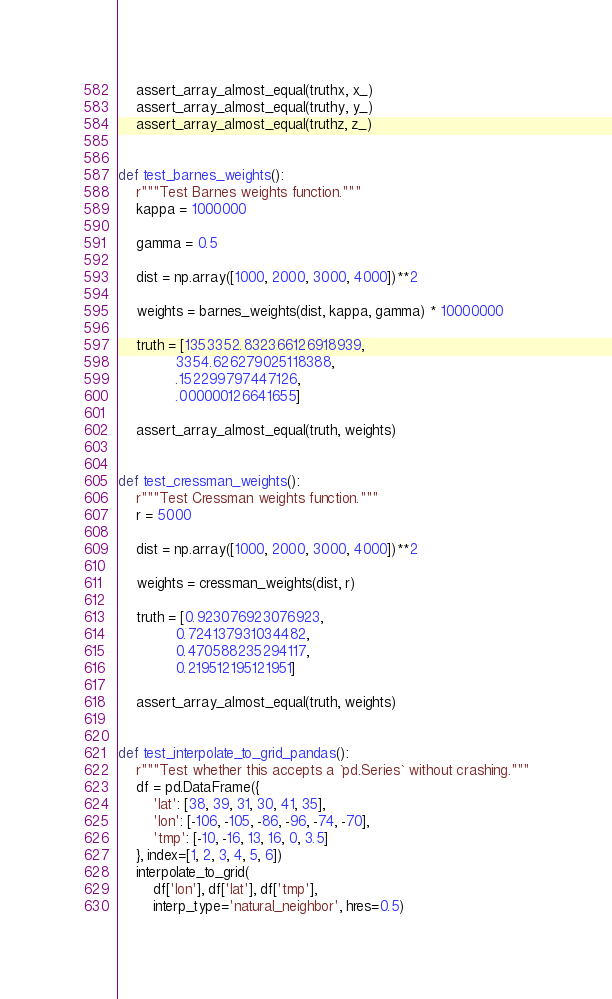Convert code to text. <code><loc_0><loc_0><loc_500><loc_500><_Python_>    assert_array_almost_equal(truthx, x_)
    assert_array_almost_equal(truthy, y_)
    assert_array_almost_equal(truthz, z_)


def test_barnes_weights():
    r"""Test Barnes weights function."""
    kappa = 1000000

    gamma = 0.5

    dist = np.array([1000, 2000, 3000, 4000])**2

    weights = barnes_weights(dist, kappa, gamma) * 10000000

    truth = [1353352.832366126918939,
             3354.626279025118388,
             .152299797447126,
             .000000126641655]

    assert_array_almost_equal(truth, weights)


def test_cressman_weights():
    r"""Test Cressman weights function."""
    r = 5000

    dist = np.array([1000, 2000, 3000, 4000])**2

    weights = cressman_weights(dist, r)

    truth = [0.923076923076923,
             0.724137931034482,
             0.470588235294117,
             0.219512195121951]

    assert_array_almost_equal(truth, weights)


def test_interpolate_to_grid_pandas():
    r"""Test whether this accepts a `pd.Series` without crashing."""
    df = pd.DataFrame({
        'lat': [38, 39, 31, 30, 41, 35],
        'lon': [-106, -105, -86, -96, -74, -70],
        'tmp': [-10, -16, 13, 16, 0, 3.5]
    }, index=[1, 2, 3, 4, 5, 6])
    interpolate_to_grid(
        df['lon'], df['lat'], df['tmp'],
        interp_type='natural_neighbor', hres=0.5)
</code> 